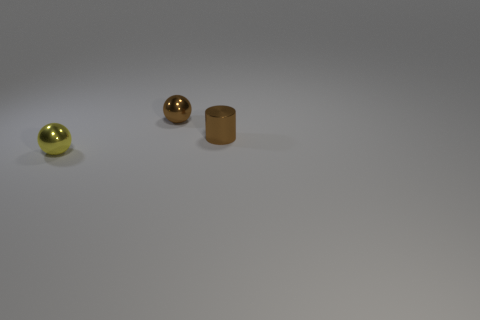Is the number of things that are on the right side of the tiny brown cylinder less than the number of tiny balls that are right of the yellow metallic sphere?
Give a very brief answer. Yes. Is the material of the ball that is behind the yellow thing the same as the thing in front of the small metallic cylinder?
Make the answer very short. Yes. What is the material of the ball that is the same color as the tiny cylinder?
Your response must be concise. Metal. There is a thing that is behind the yellow shiny object and to the left of the brown shiny cylinder; what is its shape?
Your response must be concise. Sphere. What material is the tiny ball that is to the left of the sphere that is right of the yellow thing made of?
Ensure brevity in your answer.  Metal. Are there more small brown shiny balls than balls?
Provide a succinct answer. No. What is the material of the brown cylinder that is the same size as the yellow thing?
Provide a short and direct response. Metal. Is the material of the tiny brown ball the same as the tiny yellow thing?
Keep it short and to the point. Yes. How many brown things have the same material as the tiny cylinder?
Offer a terse response. 1. How many things are tiny spheres that are in front of the cylinder or tiny metal spheres that are in front of the shiny cylinder?
Keep it short and to the point. 1. 